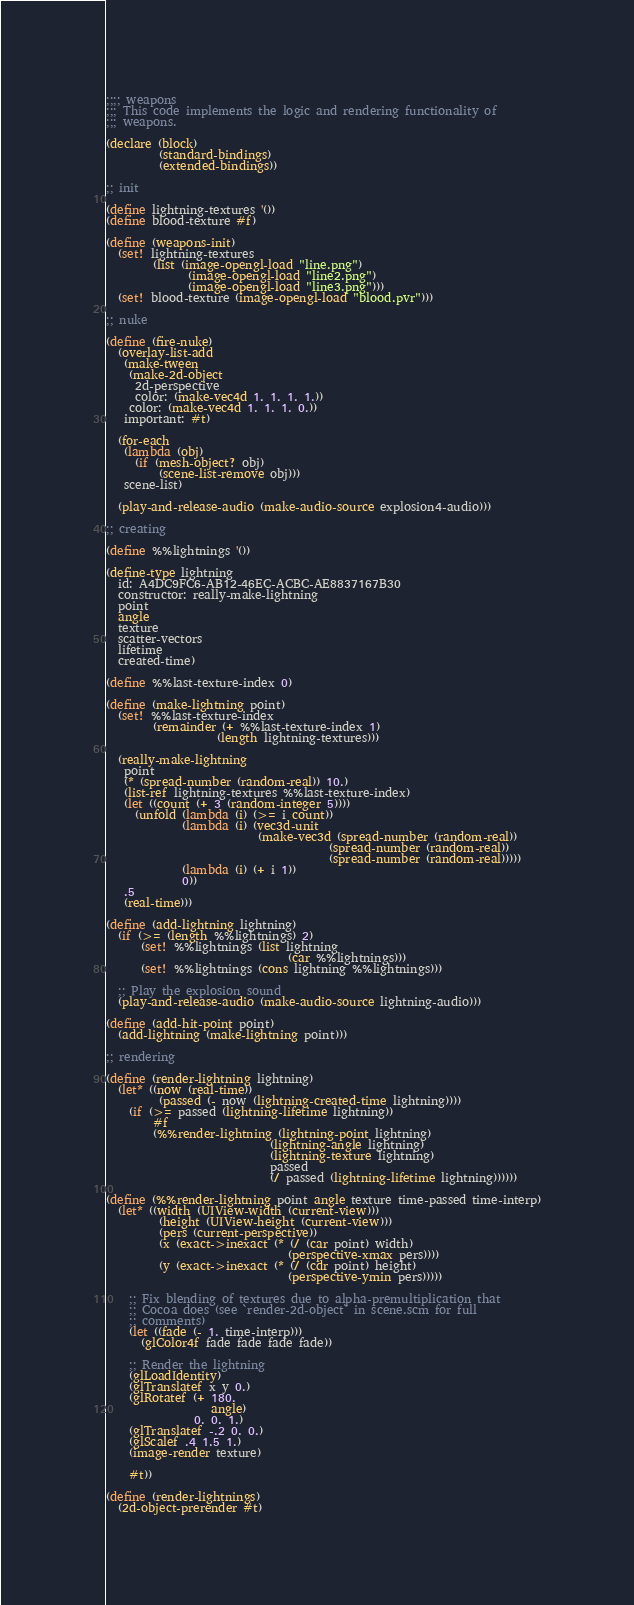<code> <loc_0><loc_0><loc_500><loc_500><_Scheme_>;;;; weapons
;;; This code implements the logic and rendering functionality of
;;; weapons.

(declare (block)
         (standard-bindings)
         (extended-bindings))

;; init

(define lightning-textures '())
(define blood-texture #f)

(define (weapons-init)
  (set! lightning-textures
        (list (image-opengl-load "line.png")
              (image-opengl-load "line2.png")
              (image-opengl-load "line3.png")))
  (set! blood-texture (image-opengl-load "blood.pvr")))

;; nuke

(define (fire-nuke)
  (overlay-list-add
   (make-tween
    (make-2d-object
     2d-perspective
     color: (make-vec4d 1. 1. 1. 1.))
    color: (make-vec4d 1. 1. 1. 0.))
   important: #t)

  (for-each
   (lambda (obj)
     (if (mesh-object? obj)
         (scene-list-remove obj)))
   scene-list)

  (play-and-release-audio (make-audio-source explosion4-audio)))

;; creating

(define %%lightnings '())

(define-type lightning
  id: A4DC9FC6-AB12-46EC-ACBC-AE8837167B30
  constructor: really-make-lightning
  point
  angle
  texture
  scatter-vectors
  lifetime
  created-time)

(define %%last-texture-index 0)

(define (make-lightning point)
  (set! %%last-texture-index
        (remainder (+ %%last-texture-index 1)
                   (length lightning-textures)))
  
  (really-make-lightning
   point
   (* (spread-number (random-real)) 10.)
   (list-ref lightning-textures %%last-texture-index)
   (let ((count (+ 3 (random-integer 5))))
     (unfold (lambda (i) (>= i count))
             (lambda (i) (vec3d-unit
                          (make-vec3d (spread-number (random-real))
                                      (spread-number (random-real))
                                      (spread-number (random-real)))))
             (lambda (i) (+ i 1))
             0))
   .5
   (real-time)))

(define (add-lightning lightning)
  (if (>= (length %%lightnings) 2)
      (set! %%lightnings (list lightning
                               (car %%lightnings)))
      (set! %%lightnings (cons lightning %%lightnings)))

  ;; Play the explosion sound
  (play-and-release-audio (make-audio-source lightning-audio)))

(define (add-hit-point point)
  (add-lightning (make-lightning point)))

;; rendering

(define (render-lightning lightning)
  (let* ((now (real-time))
         (passed (- now (lightning-created-time lightning))))
    (if (>= passed (lightning-lifetime lightning))
        #f
        (%%render-lightning (lightning-point lightning)
                            (lightning-angle lightning)
                            (lightning-texture lightning)
                            passed
                            (/ passed (lightning-lifetime lightning))))))

(define (%%render-lightning point angle texture time-passed time-interp)
  (let* ((width (UIView-width (current-view)))
         (height (UIView-height (current-view)))
         (pers (current-perspective))
         (x (exact->inexact (* (/ (car point) width)
                               (perspective-xmax pers))))
         (y (exact->inexact (* (/ (cdr point) height)
                               (perspective-ymin pers)))))

    ;; Fix blending of textures due to alpha-premultiplication that
    ;; Cocoa does (see `render-2d-object` in scene.scm for full
    ;; comments)
    (let ((fade (- 1. time-interp)))
      (glColor4f fade fade fade fade))

    ;; Render the lightning
    (glLoadIdentity)
    (glTranslatef x y 0.)
    (glRotatef (+ 180.
                  angle)
               0. 0. 1.)
    (glTranslatef -.2 0. 0.)
    (glScalef .4 1.5 1.)
    (image-render texture)

    #t))

(define (render-lightnings)
  (2d-object-prerender #t)</code> 